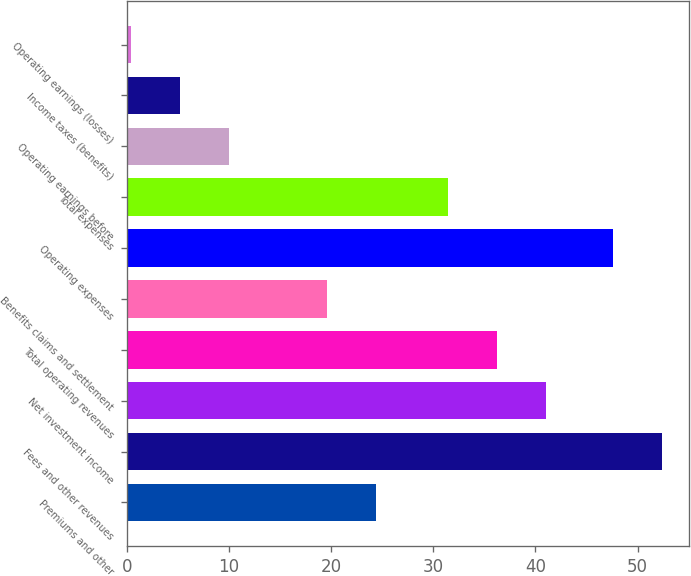Convert chart. <chart><loc_0><loc_0><loc_500><loc_500><bar_chart><fcel>Premiums and other<fcel>Fees and other revenues<fcel>Net investment income<fcel>Total operating revenues<fcel>Benefits claims and settlement<fcel>Operating expenses<fcel>Total expenses<fcel>Operating earnings before<fcel>Income taxes (benefits)<fcel>Operating earnings (losses)<nl><fcel>24.4<fcel>52.4<fcel>41<fcel>36.2<fcel>19.6<fcel>47.6<fcel>31.4<fcel>10<fcel>5.2<fcel>0.4<nl></chart> 